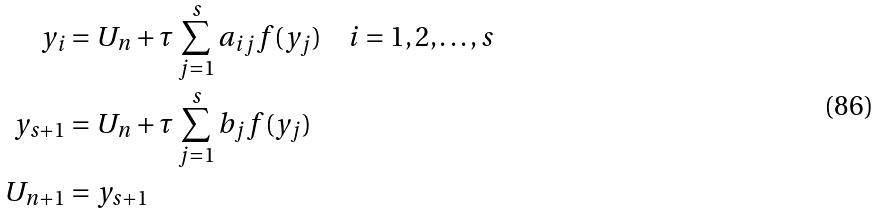<formula> <loc_0><loc_0><loc_500><loc_500>y _ { i } & = U _ { n } + \tau \sum _ { j = 1 } ^ { s } a _ { i j } f ( y _ { j } ) \quad i = 1 , 2 , \dots , s \\ y _ { s + 1 } & = U _ { n } + \tau \sum _ { j = 1 } ^ { s } b _ { j } f ( y _ { j } ) \\ U _ { n + 1 } & = y _ { s + 1 }</formula> 